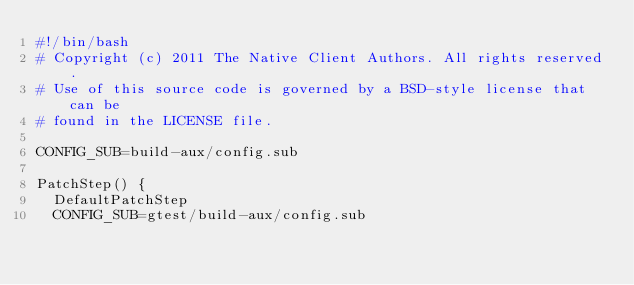Convert code to text. <code><loc_0><loc_0><loc_500><loc_500><_Bash_>#!/bin/bash
# Copyright (c) 2011 The Native Client Authors. All rights reserved.
# Use of this source code is governed by a BSD-style license that can be
# found in the LICENSE file.

CONFIG_SUB=build-aux/config.sub

PatchStep() {
  DefaultPatchStep
  CONFIG_SUB=gtest/build-aux/config.sub</code> 